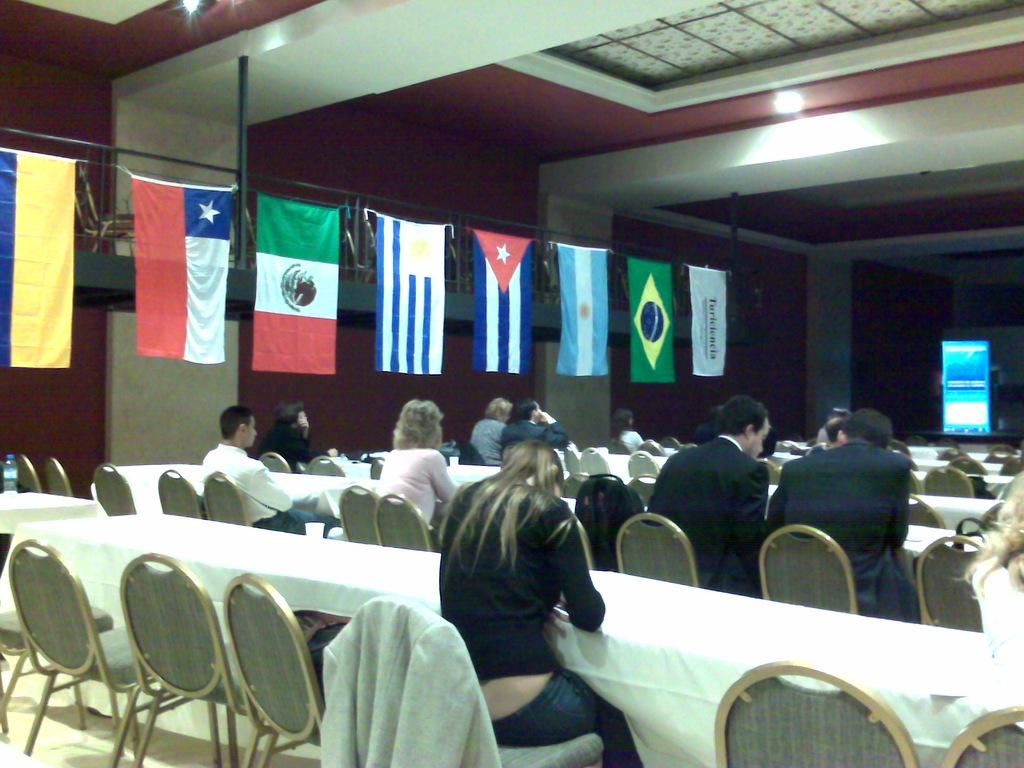How many people are in the image? There is a group of people in the image, but the exact number is not specified. What are the people doing in the image? The people are sitting in front of a table. What is the color of the table? The table is white. What can be seen on the left side of the image? There are flags on the left side of the image. What type of balls are being juggled by the achiever in the image? There is no achiever or balls present in the image. 